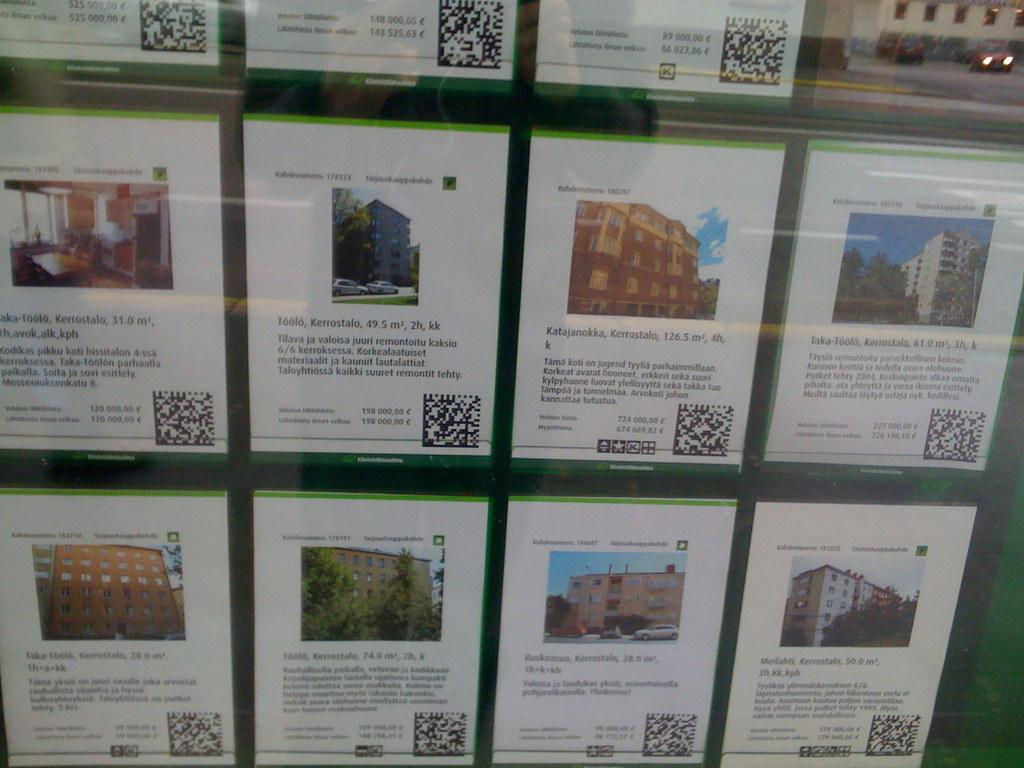<image>
Render a clear and concise summary of the photo. A display of many papers on the wall with one saying Toolo, Kerrostalo, 49.5m. 